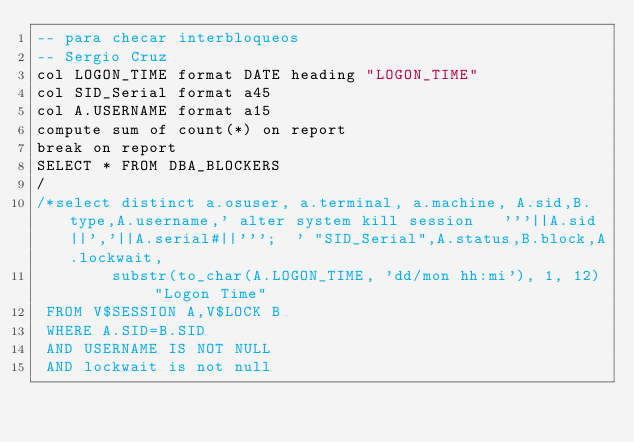Convert code to text. <code><loc_0><loc_0><loc_500><loc_500><_SQL_>-- para checar interbloqueos
-- Sergio Cruz
col LOGON_TIME format DATE heading "LOGON_TIME"
col SID_Serial format a45
col A.USERNAME format a15
compute sum of count(*) on report
break on report
SELECT * FROM DBA_BLOCKERS
/
/*select distinct a.osuser, a.terminal, a.machine, A.sid,B.type,A.username,' alter system kill session   '''||A.sid||','||A.serial#||''';  ' "SID_Serial",A.status,B.block,A.lockwait,
        substr(to_char(A.LOGON_TIME, 'dd/mon hh:mi'), 1, 12) "Logon Time"
 FROM V$SESSION A,V$LOCK B
 WHERE A.SID=B.SID
 AND USERNAME IS NOT NULL
 AND lockwait is not null</code> 